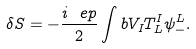<formula> <loc_0><loc_0><loc_500><loc_500>\delta S = - \frac { i \ e p } { 2 } \int b V _ { I } T ^ { I } _ { L } \psi _ { - } ^ { L } .</formula> 